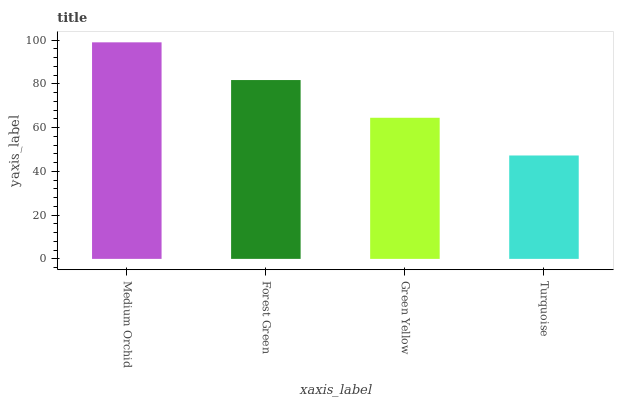Is Turquoise the minimum?
Answer yes or no. Yes. Is Medium Orchid the maximum?
Answer yes or no. Yes. Is Forest Green the minimum?
Answer yes or no. No. Is Forest Green the maximum?
Answer yes or no. No. Is Medium Orchid greater than Forest Green?
Answer yes or no. Yes. Is Forest Green less than Medium Orchid?
Answer yes or no. Yes. Is Forest Green greater than Medium Orchid?
Answer yes or no. No. Is Medium Orchid less than Forest Green?
Answer yes or no. No. Is Forest Green the high median?
Answer yes or no. Yes. Is Green Yellow the low median?
Answer yes or no. Yes. Is Turquoise the high median?
Answer yes or no. No. Is Forest Green the low median?
Answer yes or no. No. 